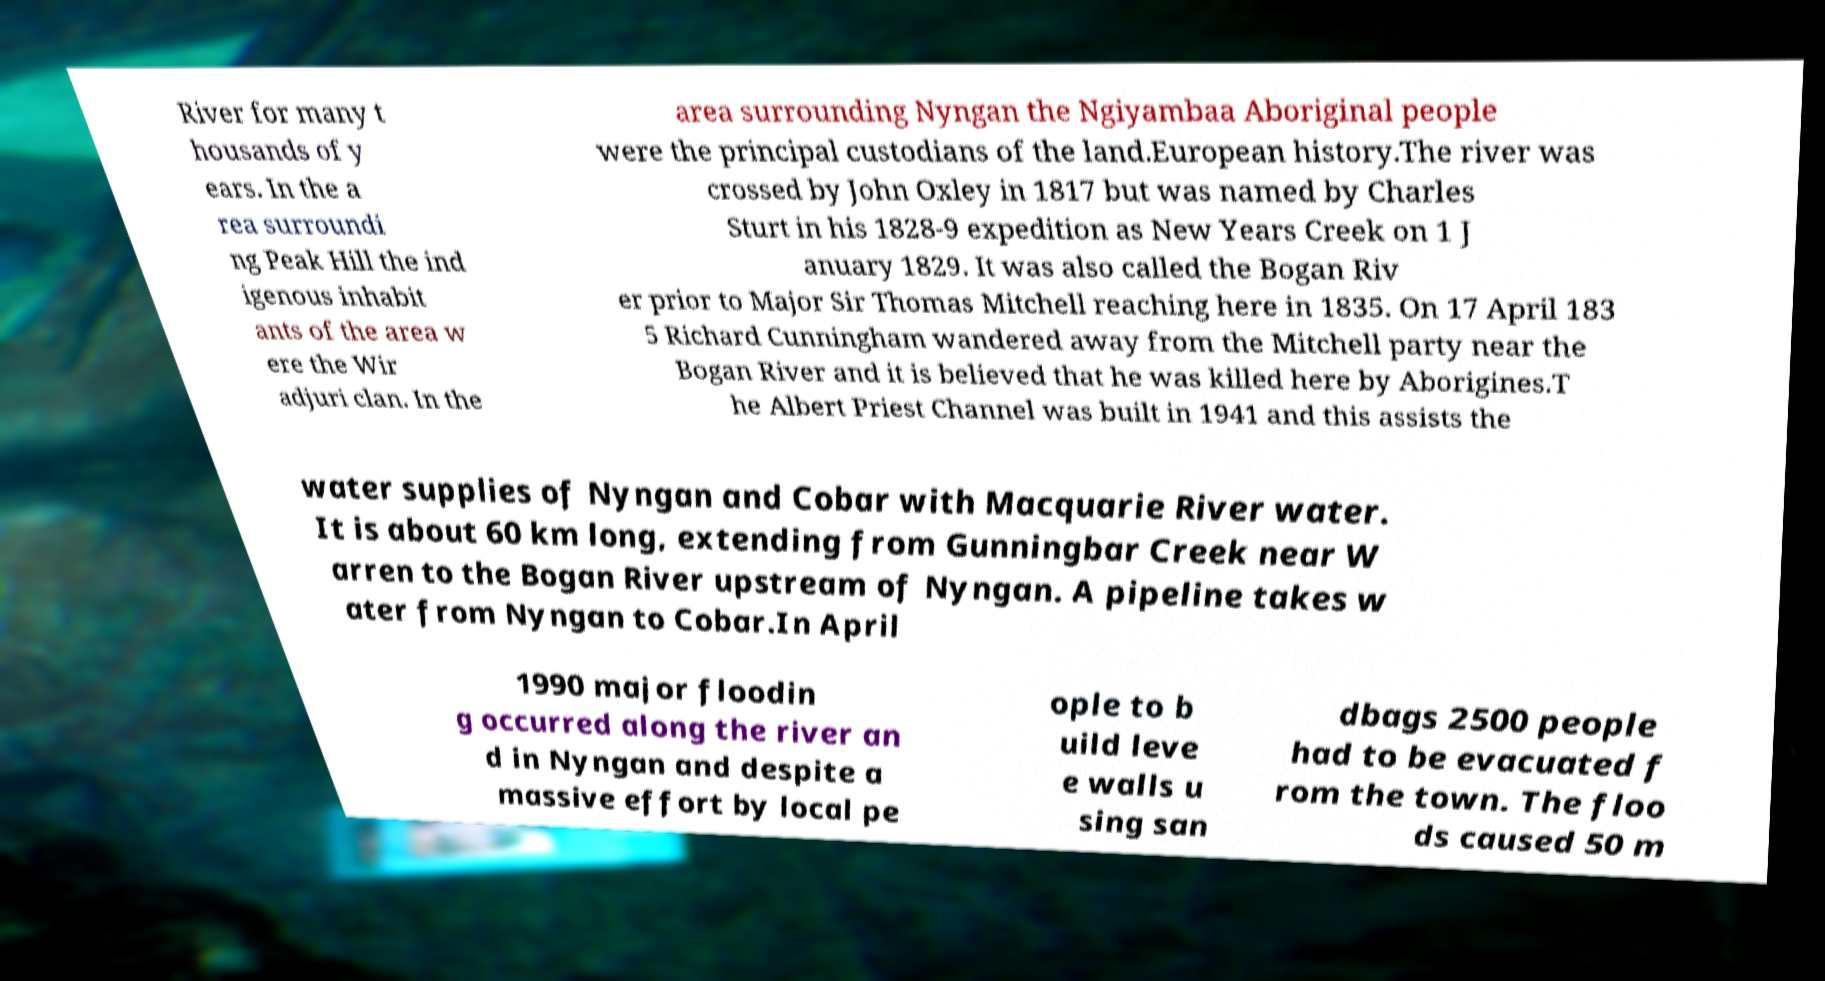Can you accurately transcribe the text from the provided image for me? River for many t housands of y ears. In the a rea surroundi ng Peak Hill the ind igenous inhabit ants of the area w ere the Wir adjuri clan. In the area surrounding Nyngan the Ngiyambaa Aboriginal people were the principal custodians of the land.European history.The river was crossed by John Oxley in 1817 but was named by Charles Sturt in his 1828-9 expedition as New Years Creek on 1 J anuary 1829. It was also called the Bogan Riv er prior to Major Sir Thomas Mitchell reaching here in 1835. On 17 April 183 5 Richard Cunningham wandered away from the Mitchell party near the Bogan River and it is believed that he was killed here by Aborigines.T he Albert Priest Channel was built in 1941 and this assists the water supplies of Nyngan and Cobar with Macquarie River water. It is about 60 km long, extending from Gunningbar Creek near W arren to the Bogan River upstream of Nyngan. A pipeline takes w ater from Nyngan to Cobar.In April 1990 major floodin g occurred along the river an d in Nyngan and despite a massive effort by local pe ople to b uild leve e walls u sing san dbags 2500 people had to be evacuated f rom the town. The floo ds caused 50 m 